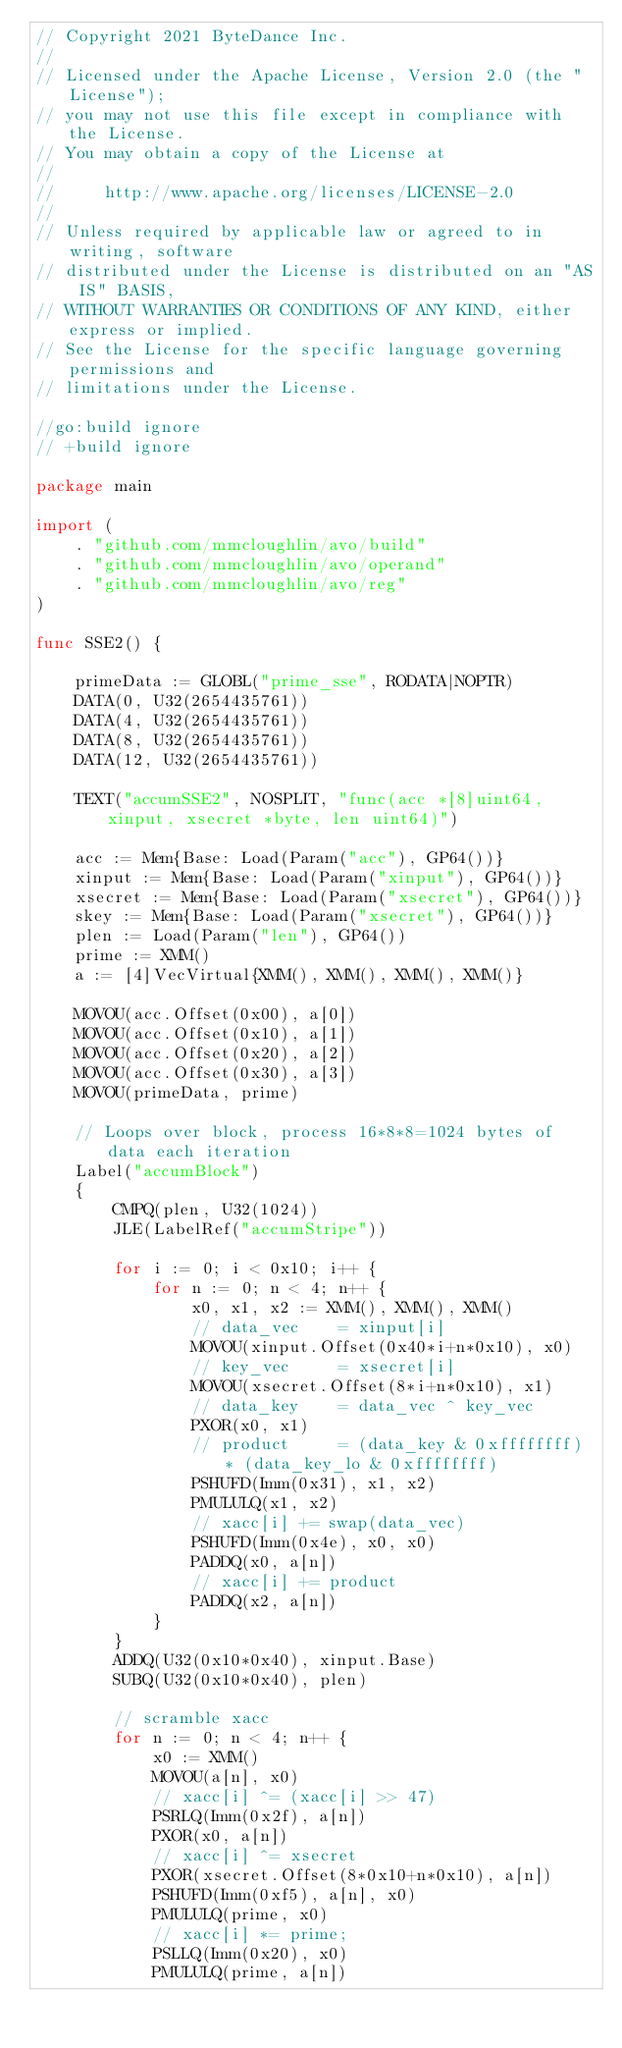Convert code to text. <code><loc_0><loc_0><loc_500><loc_500><_Go_>// Copyright 2021 ByteDance Inc.
//
// Licensed under the Apache License, Version 2.0 (the "License");
// you may not use this file except in compliance with the License.
// You may obtain a copy of the License at
//
//     http://www.apache.org/licenses/LICENSE-2.0
//
// Unless required by applicable law or agreed to in writing, software
// distributed under the License is distributed on an "AS IS" BASIS,
// WITHOUT WARRANTIES OR CONDITIONS OF ANY KIND, either express or implied.
// See the License for the specific language governing permissions and
// limitations under the License.

//go:build ignore
// +build ignore

package main

import (
	. "github.com/mmcloughlin/avo/build"
	. "github.com/mmcloughlin/avo/operand"
	. "github.com/mmcloughlin/avo/reg"
)

func SSE2() {

	primeData := GLOBL("prime_sse", RODATA|NOPTR)
	DATA(0, U32(2654435761))
	DATA(4, U32(2654435761))
	DATA(8, U32(2654435761))
	DATA(12, U32(2654435761))

	TEXT("accumSSE2", NOSPLIT, "func(acc *[8]uint64, xinput, xsecret *byte, len uint64)")

	acc := Mem{Base: Load(Param("acc"), GP64())}
	xinput := Mem{Base: Load(Param("xinput"), GP64())}
	xsecret := Mem{Base: Load(Param("xsecret"), GP64())}
	skey := Mem{Base: Load(Param("xsecret"), GP64())}
	plen := Load(Param("len"), GP64())
	prime := XMM()
	a := [4]VecVirtual{XMM(), XMM(), XMM(), XMM()}

	MOVOU(acc.Offset(0x00), a[0])
	MOVOU(acc.Offset(0x10), a[1])
	MOVOU(acc.Offset(0x20), a[2])
	MOVOU(acc.Offset(0x30), a[3])
	MOVOU(primeData, prime)

	// Loops over block, process 16*8*8=1024 bytes of data each iteration
	Label("accumBlock")
	{
		CMPQ(plen, U32(1024))
		JLE(LabelRef("accumStripe"))

		for i := 0; i < 0x10; i++ {
			for n := 0; n < 4; n++ {
				x0, x1, x2 := XMM(), XMM(), XMM()
				// data_vec    = xinput[i]
				MOVOU(xinput.Offset(0x40*i+n*0x10), x0)
				// key_vec     = xsecret[i]
				MOVOU(xsecret.Offset(8*i+n*0x10), x1)
				// data_key    = data_vec ^ key_vec
				PXOR(x0, x1)
				// product     = (data_key & 0xffffffff) * (data_key_lo & 0xffffffff)
				PSHUFD(Imm(0x31), x1, x2)
				PMULULQ(x1, x2)
				// xacc[i] += swap(data_vec)
				PSHUFD(Imm(0x4e), x0, x0)
				PADDQ(x0, a[n])
				// xacc[i] += product
				PADDQ(x2, a[n])
			}
		}
		ADDQ(U32(0x10*0x40), xinput.Base)
		SUBQ(U32(0x10*0x40), plen)

		// scramble xacc
		for n := 0; n < 4; n++ {
			x0 := XMM()
			MOVOU(a[n], x0)
			// xacc[i] ^= (xacc[i] >> 47)
			PSRLQ(Imm(0x2f), a[n])
			PXOR(x0, a[n])
			// xacc[i] ^= xsecret
			PXOR(xsecret.Offset(8*0x10+n*0x10), a[n])
			PSHUFD(Imm(0xf5), a[n], x0)
			PMULULQ(prime, x0)
			// xacc[i] *= prime;
			PSLLQ(Imm(0x20), x0)
			PMULULQ(prime, a[n])</code> 